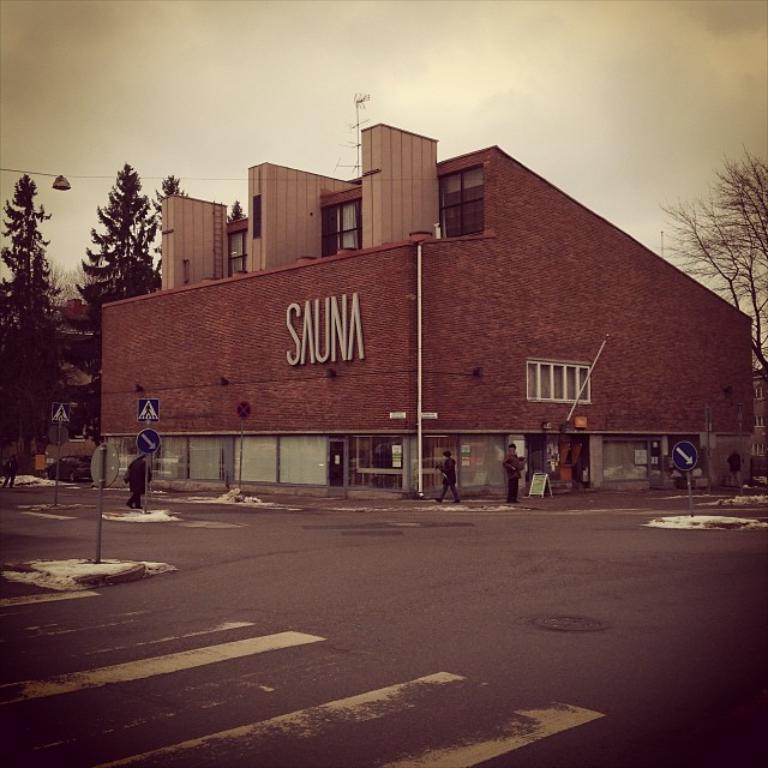Could you give a brief overview of what you see in this image? In this image there is a road at the bottom. In the middle there is a building. There are trees on either side of the building. There are sign boards on the footpath. There are few people walking on the footpath. 